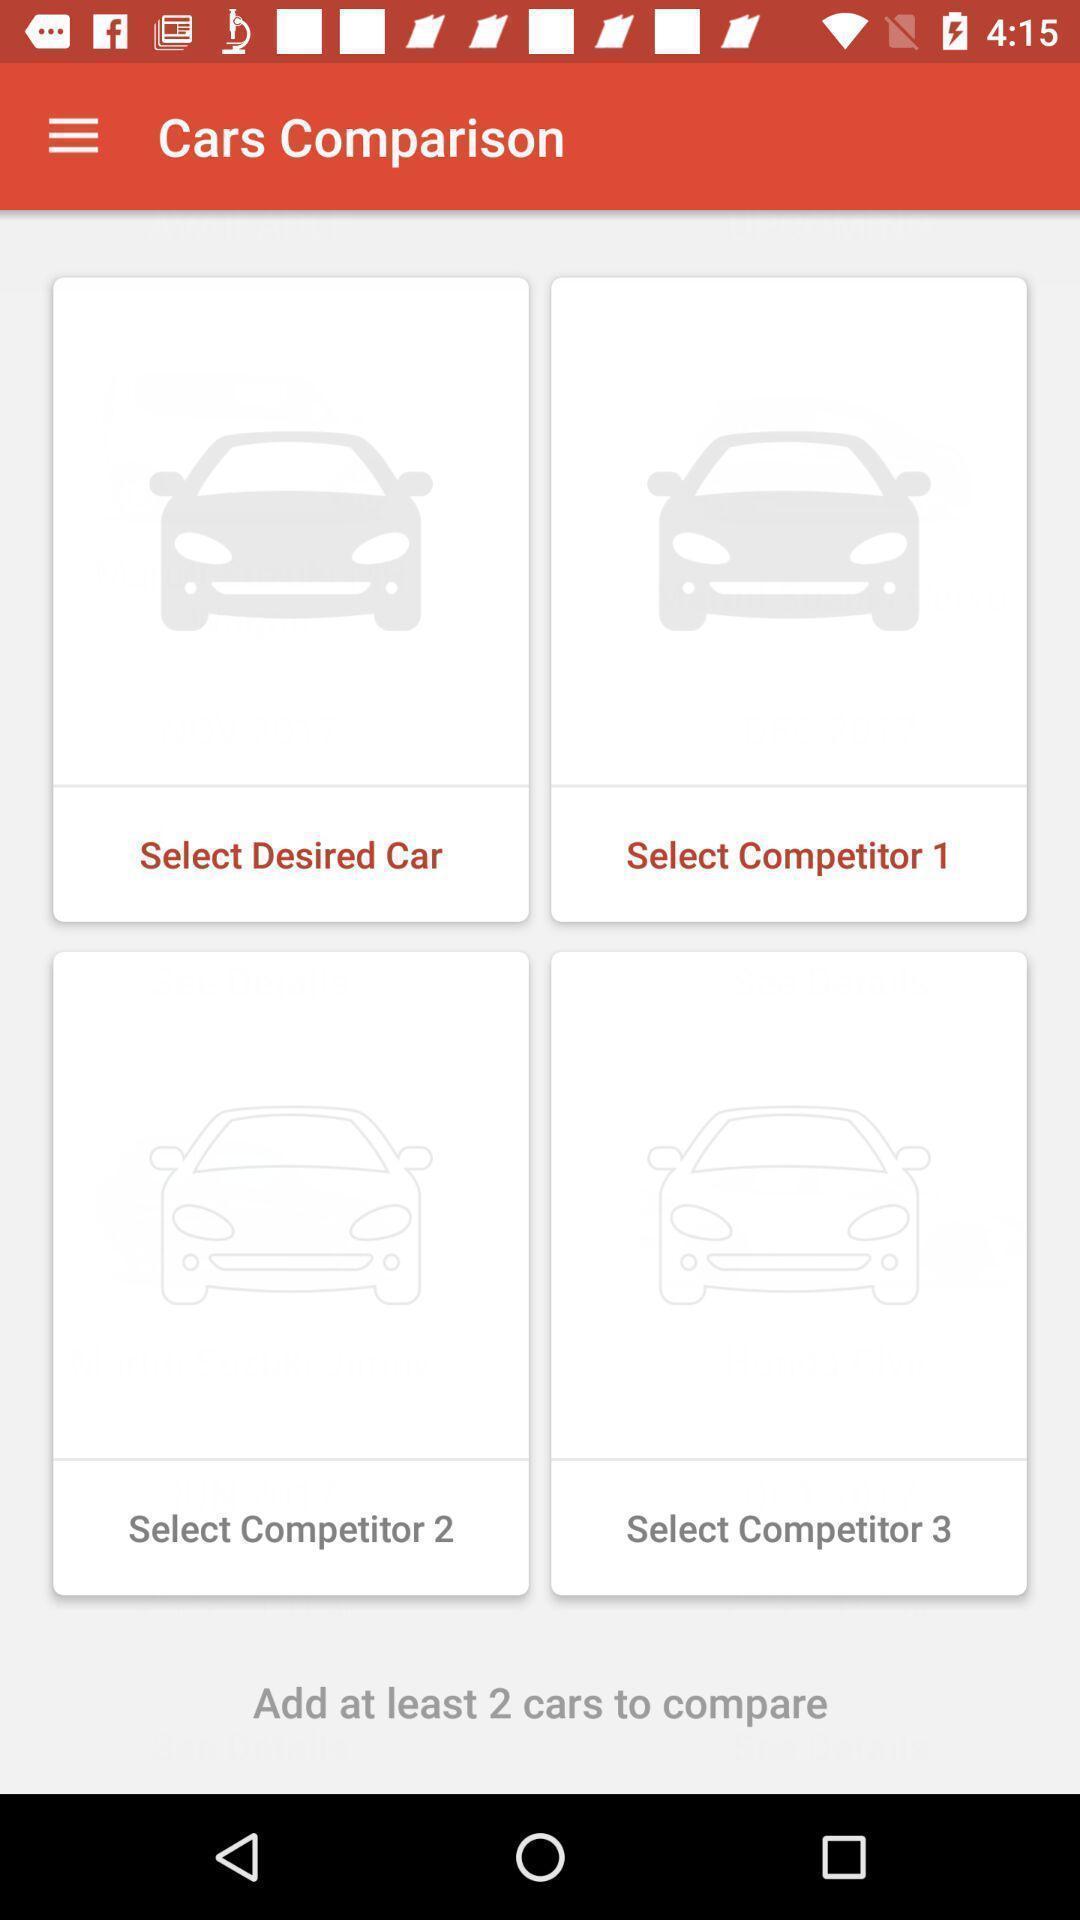Provide a detailed account of this screenshot. Page displaying the multiple car. 